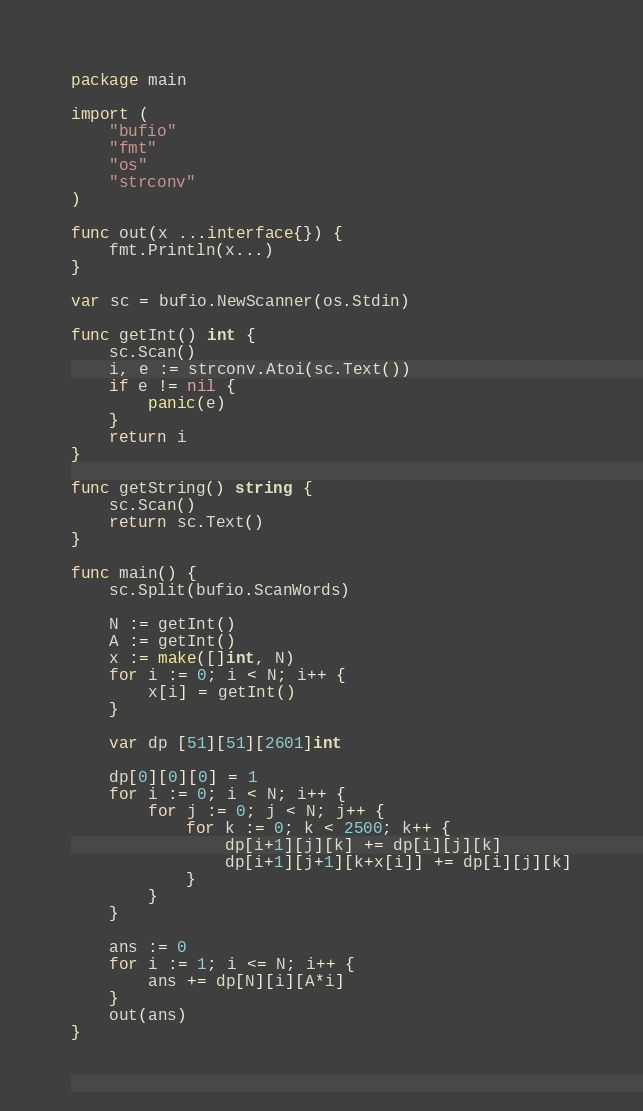<code> <loc_0><loc_0><loc_500><loc_500><_Go_>package main

import (
	"bufio"
	"fmt"
	"os"
	"strconv"
)

func out(x ...interface{}) {
	fmt.Println(x...)
}

var sc = bufio.NewScanner(os.Stdin)

func getInt() int {
	sc.Scan()
	i, e := strconv.Atoi(sc.Text())
	if e != nil {
		panic(e)
	}
	return i
}

func getString() string {
	sc.Scan()
	return sc.Text()
}

func main() {
	sc.Split(bufio.ScanWords)

	N := getInt()
	A := getInt()
	x := make([]int, N)
	for i := 0; i < N; i++ {
		x[i] = getInt()
	}

	var dp [51][51][2601]int

	dp[0][0][0] = 1
	for i := 0; i < N; i++ {
		for j := 0; j < N; j++ {
			for k := 0; k < 2500; k++ {
				dp[i+1][j][k] += dp[i][j][k]
				dp[i+1][j+1][k+x[i]] += dp[i][j][k]
			}
		}
	}

	ans := 0
	for i := 1; i <= N; i++ {
		ans += dp[N][i][A*i]
	}
	out(ans)
}
</code> 